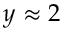Convert formula to latex. <formula><loc_0><loc_0><loc_500><loc_500>y \approx 2</formula> 